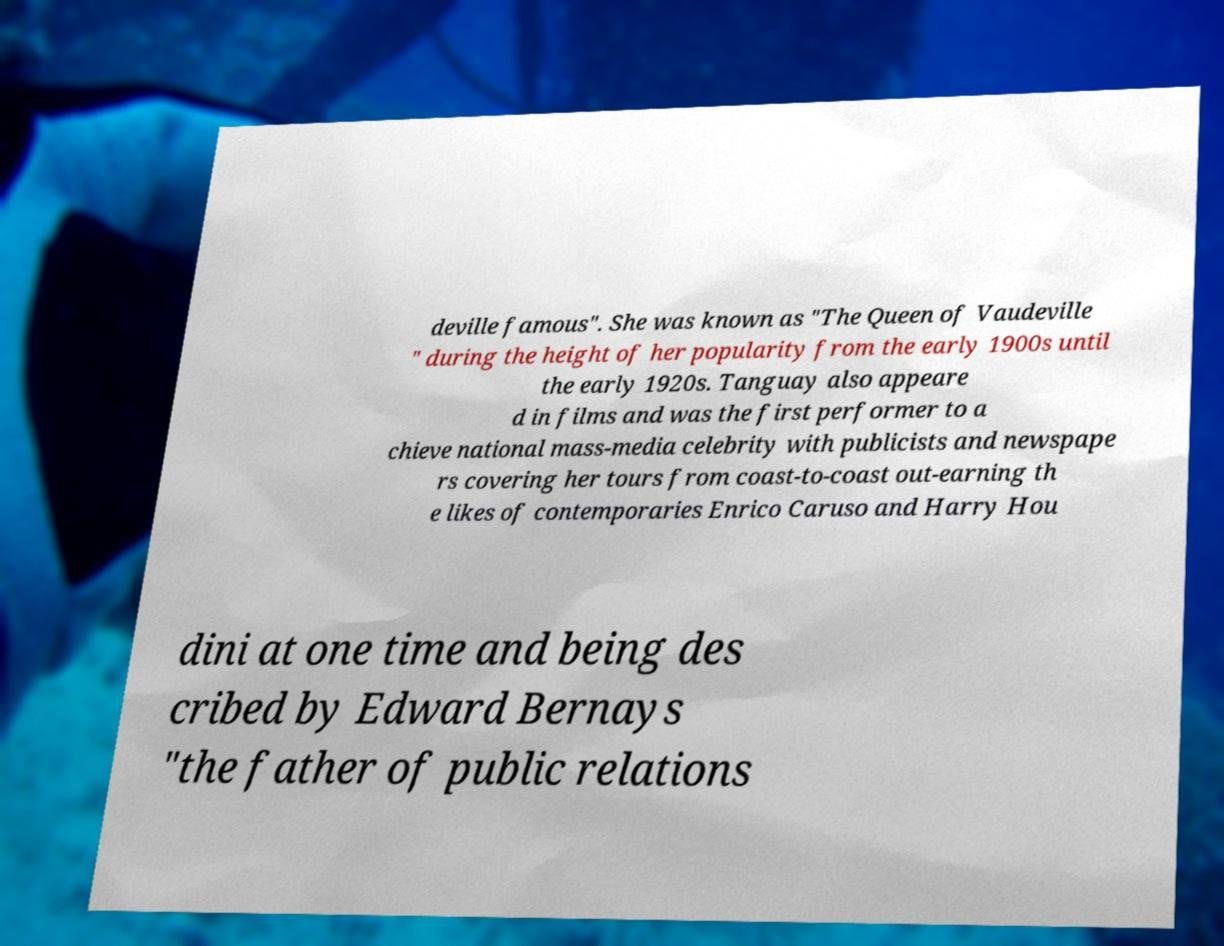There's text embedded in this image that I need extracted. Can you transcribe it verbatim? deville famous". She was known as "The Queen of Vaudeville " during the height of her popularity from the early 1900s until the early 1920s. Tanguay also appeare d in films and was the first performer to a chieve national mass-media celebrity with publicists and newspape rs covering her tours from coast-to-coast out-earning th e likes of contemporaries Enrico Caruso and Harry Hou dini at one time and being des cribed by Edward Bernays "the father of public relations 